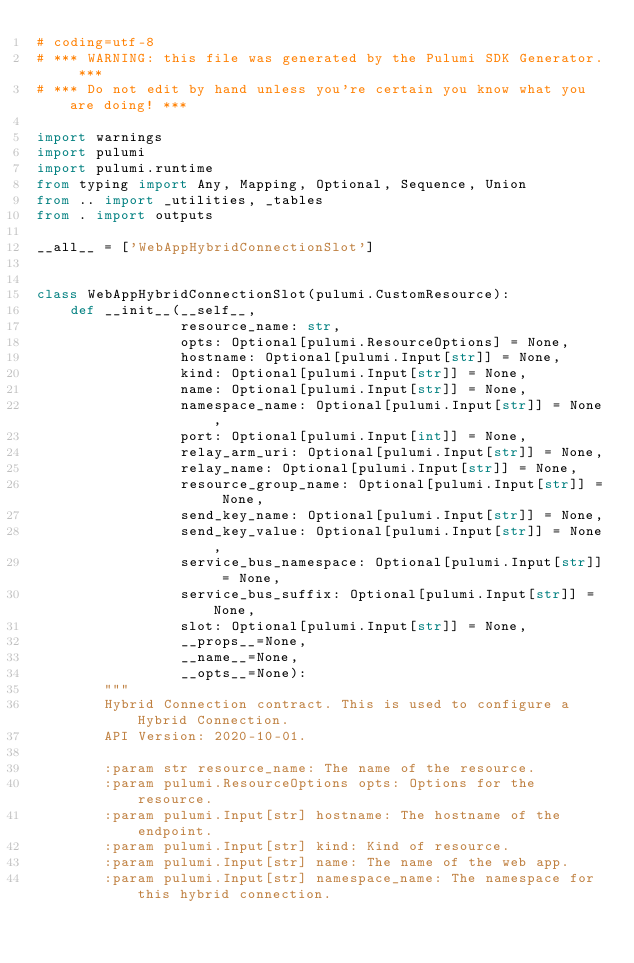<code> <loc_0><loc_0><loc_500><loc_500><_Python_># coding=utf-8
# *** WARNING: this file was generated by the Pulumi SDK Generator. ***
# *** Do not edit by hand unless you're certain you know what you are doing! ***

import warnings
import pulumi
import pulumi.runtime
from typing import Any, Mapping, Optional, Sequence, Union
from .. import _utilities, _tables
from . import outputs

__all__ = ['WebAppHybridConnectionSlot']


class WebAppHybridConnectionSlot(pulumi.CustomResource):
    def __init__(__self__,
                 resource_name: str,
                 opts: Optional[pulumi.ResourceOptions] = None,
                 hostname: Optional[pulumi.Input[str]] = None,
                 kind: Optional[pulumi.Input[str]] = None,
                 name: Optional[pulumi.Input[str]] = None,
                 namespace_name: Optional[pulumi.Input[str]] = None,
                 port: Optional[pulumi.Input[int]] = None,
                 relay_arm_uri: Optional[pulumi.Input[str]] = None,
                 relay_name: Optional[pulumi.Input[str]] = None,
                 resource_group_name: Optional[pulumi.Input[str]] = None,
                 send_key_name: Optional[pulumi.Input[str]] = None,
                 send_key_value: Optional[pulumi.Input[str]] = None,
                 service_bus_namespace: Optional[pulumi.Input[str]] = None,
                 service_bus_suffix: Optional[pulumi.Input[str]] = None,
                 slot: Optional[pulumi.Input[str]] = None,
                 __props__=None,
                 __name__=None,
                 __opts__=None):
        """
        Hybrid Connection contract. This is used to configure a Hybrid Connection.
        API Version: 2020-10-01.

        :param str resource_name: The name of the resource.
        :param pulumi.ResourceOptions opts: Options for the resource.
        :param pulumi.Input[str] hostname: The hostname of the endpoint.
        :param pulumi.Input[str] kind: Kind of resource.
        :param pulumi.Input[str] name: The name of the web app.
        :param pulumi.Input[str] namespace_name: The namespace for this hybrid connection.</code> 